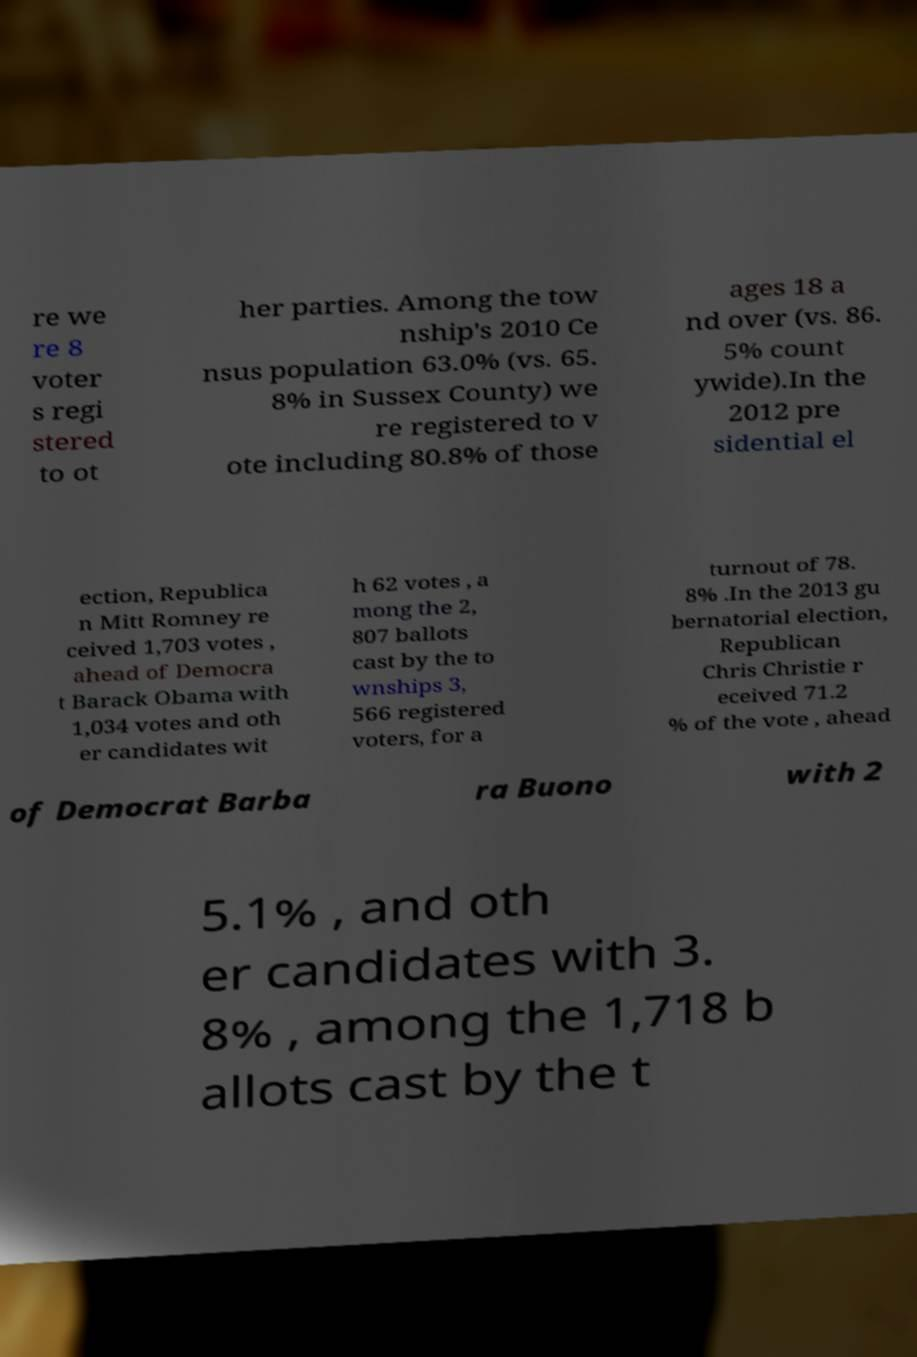Please identify and transcribe the text found in this image. re we re 8 voter s regi stered to ot her parties. Among the tow nship's 2010 Ce nsus population 63.0% (vs. 65. 8% in Sussex County) we re registered to v ote including 80.8% of those ages 18 a nd over (vs. 86. 5% count ywide).In the 2012 pre sidential el ection, Republica n Mitt Romney re ceived 1,703 votes , ahead of Democra t Barack Obama with 1,034 votes and oth er candidates wit h 62 votes , a mong the 2, 807 ballots cast by the to wnships 3, 566 registered voters, for a turnout of 78. 8% .In the 2013 gu bernatorial election, Republican Chris Christie r eceived 71.2 % of the vote , ahead of Democrat Barba ra Buono with 2 5.1% , and oth er candidates with 3. 8% , among the 1,718 b allots cast by the t 